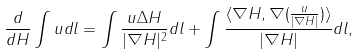Convert formula to latex. <formula><loc_0><loc_0><loc_500><loc_500>\frac { d } { d H } \int u d l = \int \frac { u \Delta H } { | \nabla H | ^ { 2 } } d l + \int \frac { \langle \nabla H , \nabla ( \frac { u } { | \nabla H | } ) \rangle } { | \nabla H | } d l ,</formula> 